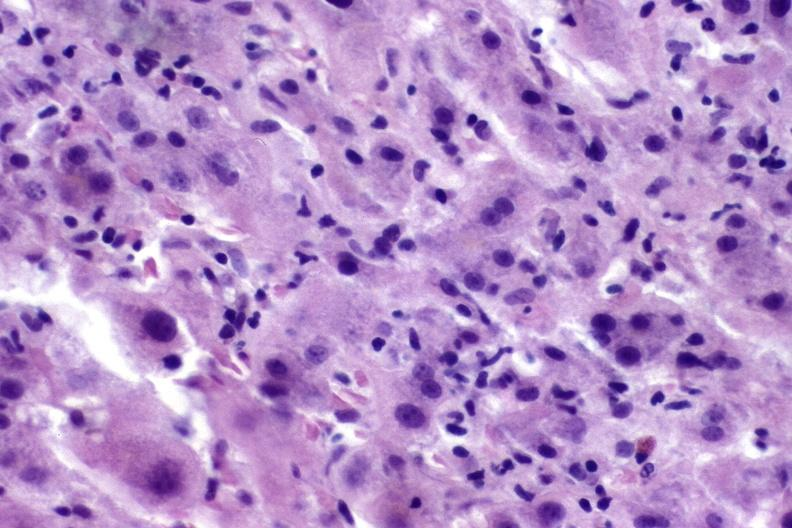what does this image show?
Answer the question using a single word or phrase. Autoimmune hepatitis 